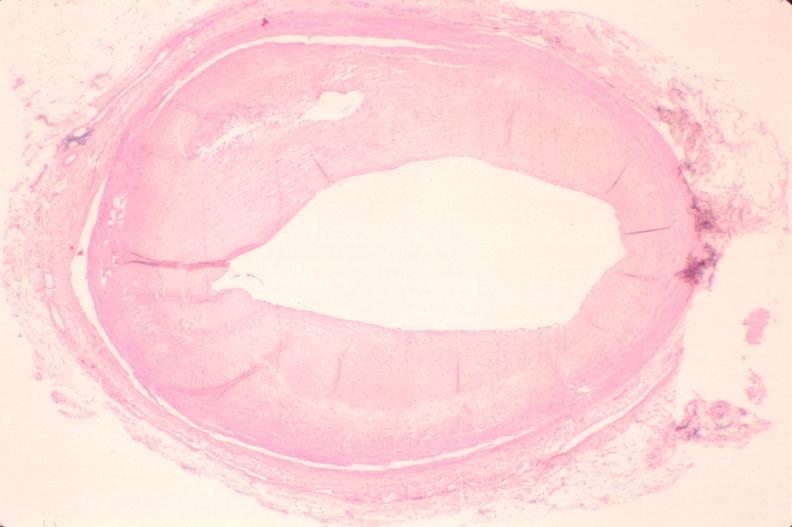what is present?
Answer the question using a single word or phrase. Cardiovascular 